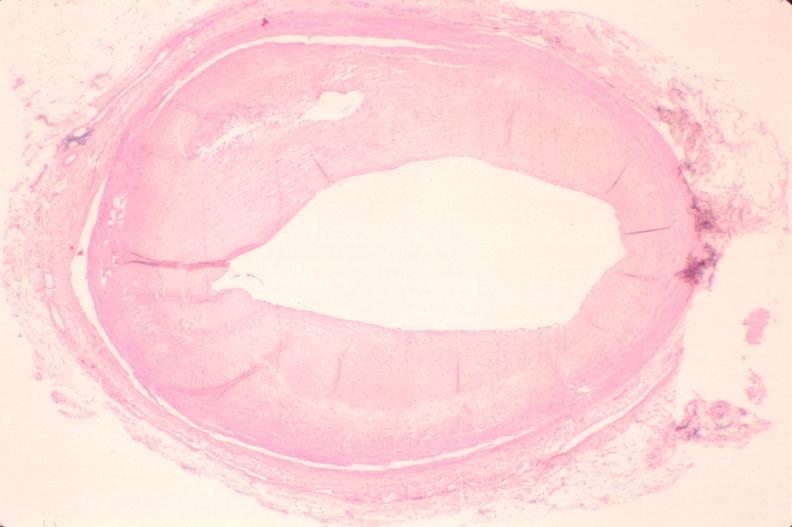what is present?
Answer the question using a single word or phrase. Cardiovascular 